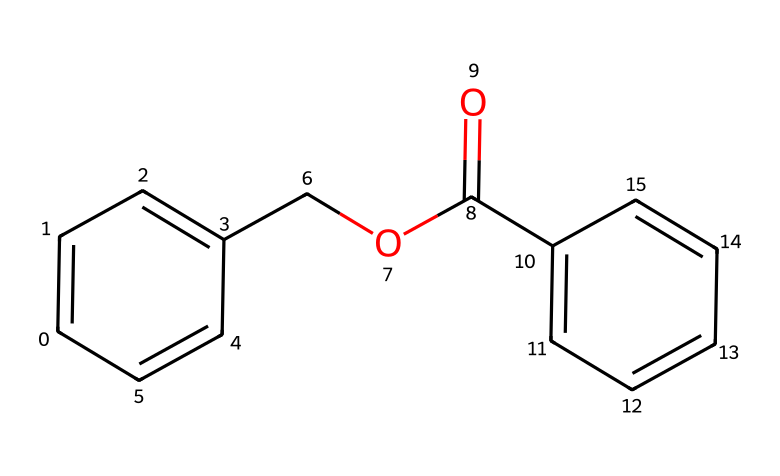What is the total number of carbon atoms in benzyl benzoate? By examining the SMILES representation, we see each 'C' represents a carbon atom. We can count the instances of 'C' and include those in branches. There are 15 carbon atoms in total (C1, C2, C3...C15).
Answer: 15 How many aromatic rings are present in the structure? In the SMILES representation, "C1=CC=C" indicates the presence of benzene rings. Notably, there are two such segments, which suggests two aromatic rings in the compound.
Answer: 2 What functional group is indicated by "COC(=O)" in the structure? The "O" and "C(=O)" in the SMILES represent an ester functional group. This can be concluded because the carbon is double-bonded to oxygen while being also single-bonded to another oxygen that is connected to a carbon.
Answer: ester What is the primary use of benzyl benzoate in historical contexts? Benzyl benzoate has been used historically as a fixative in fragrances. Fixatives are used to stabilize and prolong the scent of perfumes and can also assist in fabric treatments.
Answer: fixative What makes benzyl benzoate an aromatic compound? The presence of alternating double bonds in the aromatic rings (indicated by the 'C=C' linkages in the structure) classifies it as an aromatic compound. The structure demonstrates resonance stability typical of aromaticity.
Answer: resonance stability 